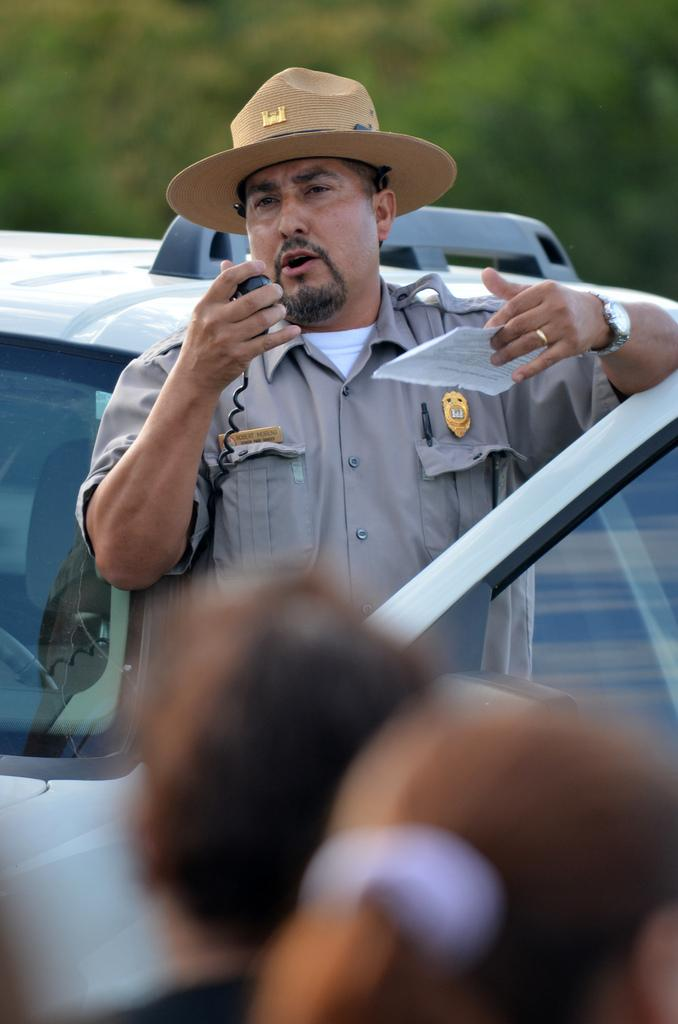How many people are in the image? There are people in the image, but the exact number is not specified. What is the man holding in the image? The man is holding a paper and a device in the image. What can be seen in the image besides the people? There is a vehicle in the image. Can you describe the background of the image? The background of the image is blurry. How many nuts are visible in the image? There are no nuts present in the image. What color are the man's eyes in the image? The color of the man's eyes is not mentioned in the image, so it cannot be determined. 